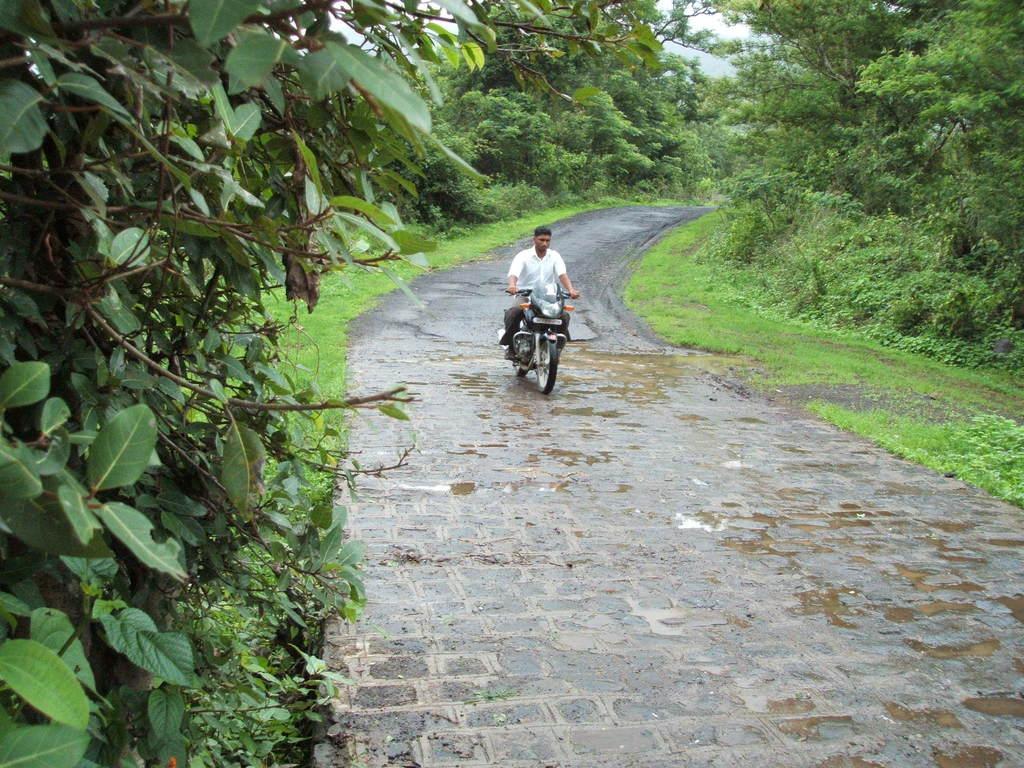Describe this image in one or two sentences. In the center of the image we can see a man riding on the bike. In the background there are trees and sky. At the bottom there is a road. 